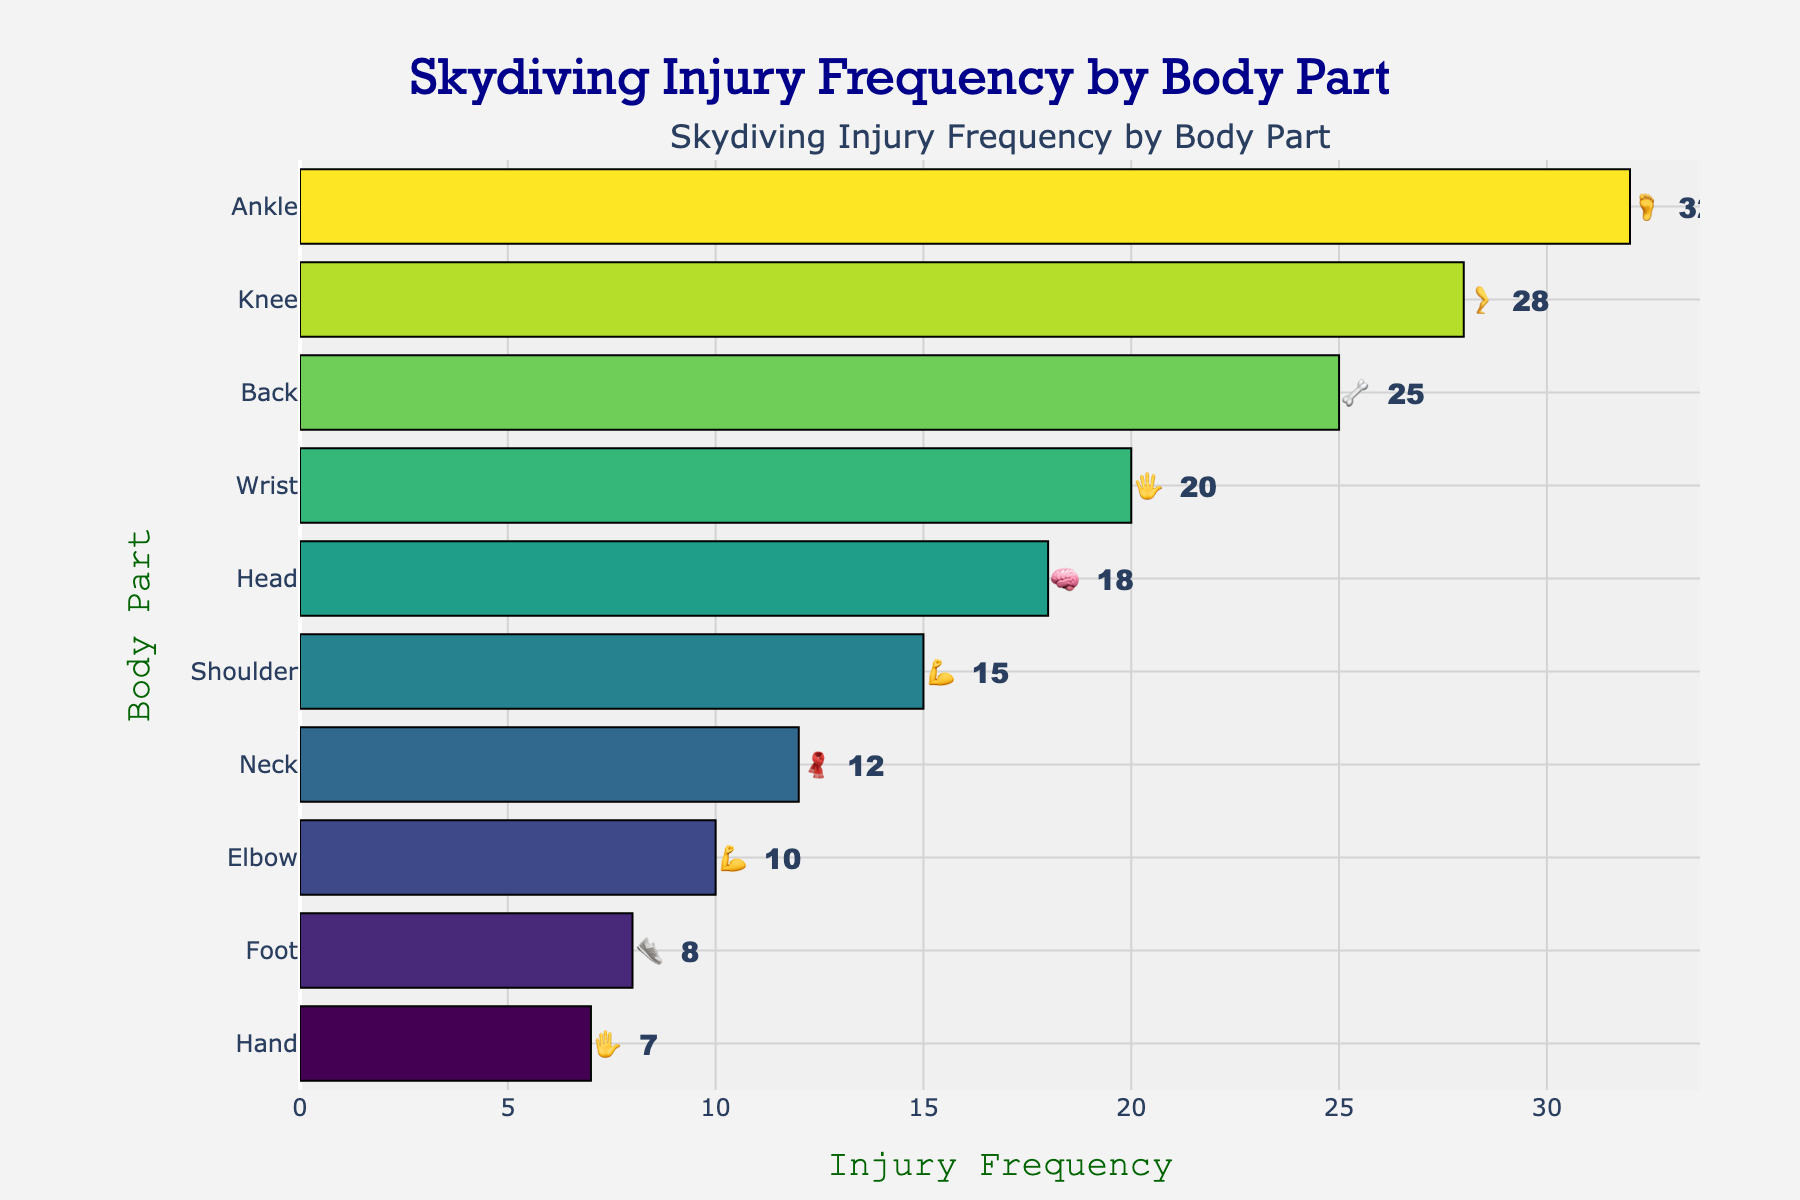What is the most common body part injured in skydiving? The horizontal bar chart shows injury frequency by body part, and the bar for "Ankle 🦶" extends the farthest right, indicating it has the highest frequency.
Answer: Ankle 🦶 Which body part has the least frequent injuries? The horizontal bar chart shows injury frequency, and the shortest bar corresponds to "Hand ✋."
Answer: Hand ✋ How many more injuries does the head 🧠 have compared to the hand ✋? The bar length for "Head 🧠" indicates 18 injuries, while "Hand ✋" has 7 injuries. The difference is 18 - 7 = 11.
Answer: 11 Arrange the body parts in descending order of injury frequency. Reading from the longest to the shortest bars: Ankle 🦶 (32), Knee 🦵 (28), Back 🦴 (25), Wrist 🖐️ (20), Head 🧠 (18), Shoulder 💪 (15), Neck 🧣 (12), Elbow 💪 (10), Foot 👟 (8), Hand ✋ (7).
Answer: Ankle 🦶, Knee 🦵, Back 🦴, Wrist 🖐️, Head 🧠, Shoulder 💪, Neck 🧣, Elbow 💪, Foot 👟, Hand ✋ How many total injuries are represented in the chart? Sum the frequencies provided for each body part: 32 (Ankle) + 28 (Knee) + 25 (Back) + 20 (Wrist) + 18 (Head) + 15 (Shoulder) + 12 (Neck) + 10 (Elbow) + 8 (Foot) + 7 (Hand) = 175.
Answer: 175 What is the difference in injury frequency between wrist 🖐️ and shoulder 💪? The wrist 🖐️ has an injury frequency of 20 while shoulder 💪 has 15. The difference is 20 - 15 = 5.
Answer: 5 Which two body parts have the closest injury frequencies? The chart's bars show that "Elbow 💪" with 10 injuries and "Neck 🧣" with 12 injuries are closest, with a difference of only 2.
Answer: Elbow 💪 and Neck 🧣 What is the average injury frequency for the top three most injured body parts? The top three body parts are Ankle 🦶 (32), Knee 🦵 (28), and Back 🦴 (25). Their average is (32 + 28 + 25) / 3 = 85 / 3 ≈ 28.33.
Answer: 28.33 Does any body part have exactly twice the frequency of another part? The bar lengths correlate to the frequencies; there isn't any pair where one is exactly twice the other.
Answer: No What is the median injury frequency of all body parts? List frequencies in order: 7, 8, 10, 12, 15, 18, 20, 25, 28, 32. The middle values are 15 and 18, so median = (15 + 18) / 2 = 16.5.
Answer: 16.5 